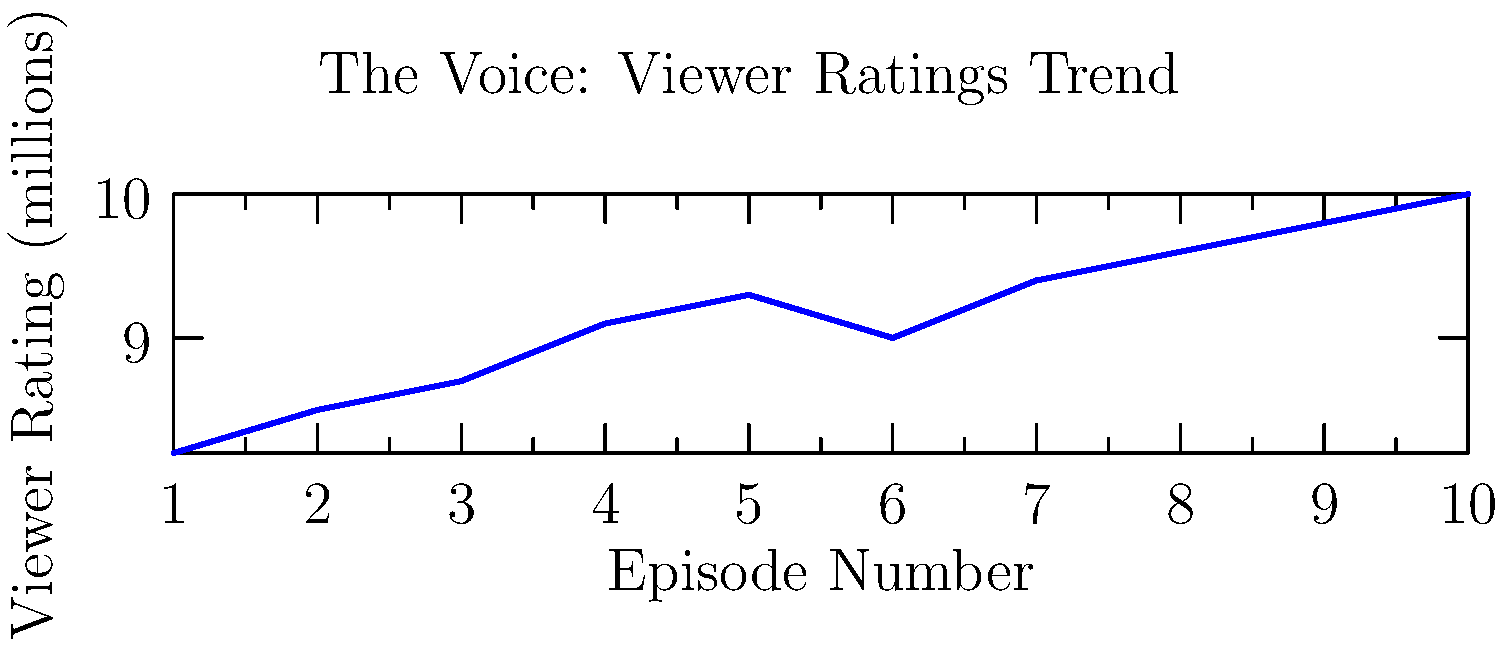Based on the viewer ratings trend for "The Voice" shown in the graph, what is the most likely prediction for the viewer rating (in millions) for the next episode? To predict the viewer rating for the next episode, we need to analyze the trend in the given data:

1. Observe the overall trend: The graph shows a general upward trend in viewer ratings over the episodes.

2. Calculate the average increase:
   - First episode: 8.2 million
   - Last episode: 10.0 million
   - Total increase: 10.0 - 8.2 = 1.8 million
   - Average increase per episode: 1.8 / 9 ≈ 0.2 million

3. Look at recent episodes:
   - The last few episodes show a consistent increase of about 0.2 million viewers per episode.

4. Predict the next episode:
   - Last episode rating: 10.0 million
   - Expected increase: 0.2 million
   - Predicted rating: 10.0 + 0.2 = 10.2 million

5. Round the prediction:
   Given the nature of TV ratings, it's reasonable to round to the nearest 0.1 million.

Therefore, the most likely prediction for the viewer rating of the next episode is 10.2 million viewers.
Answer: 10.2 million viewers 